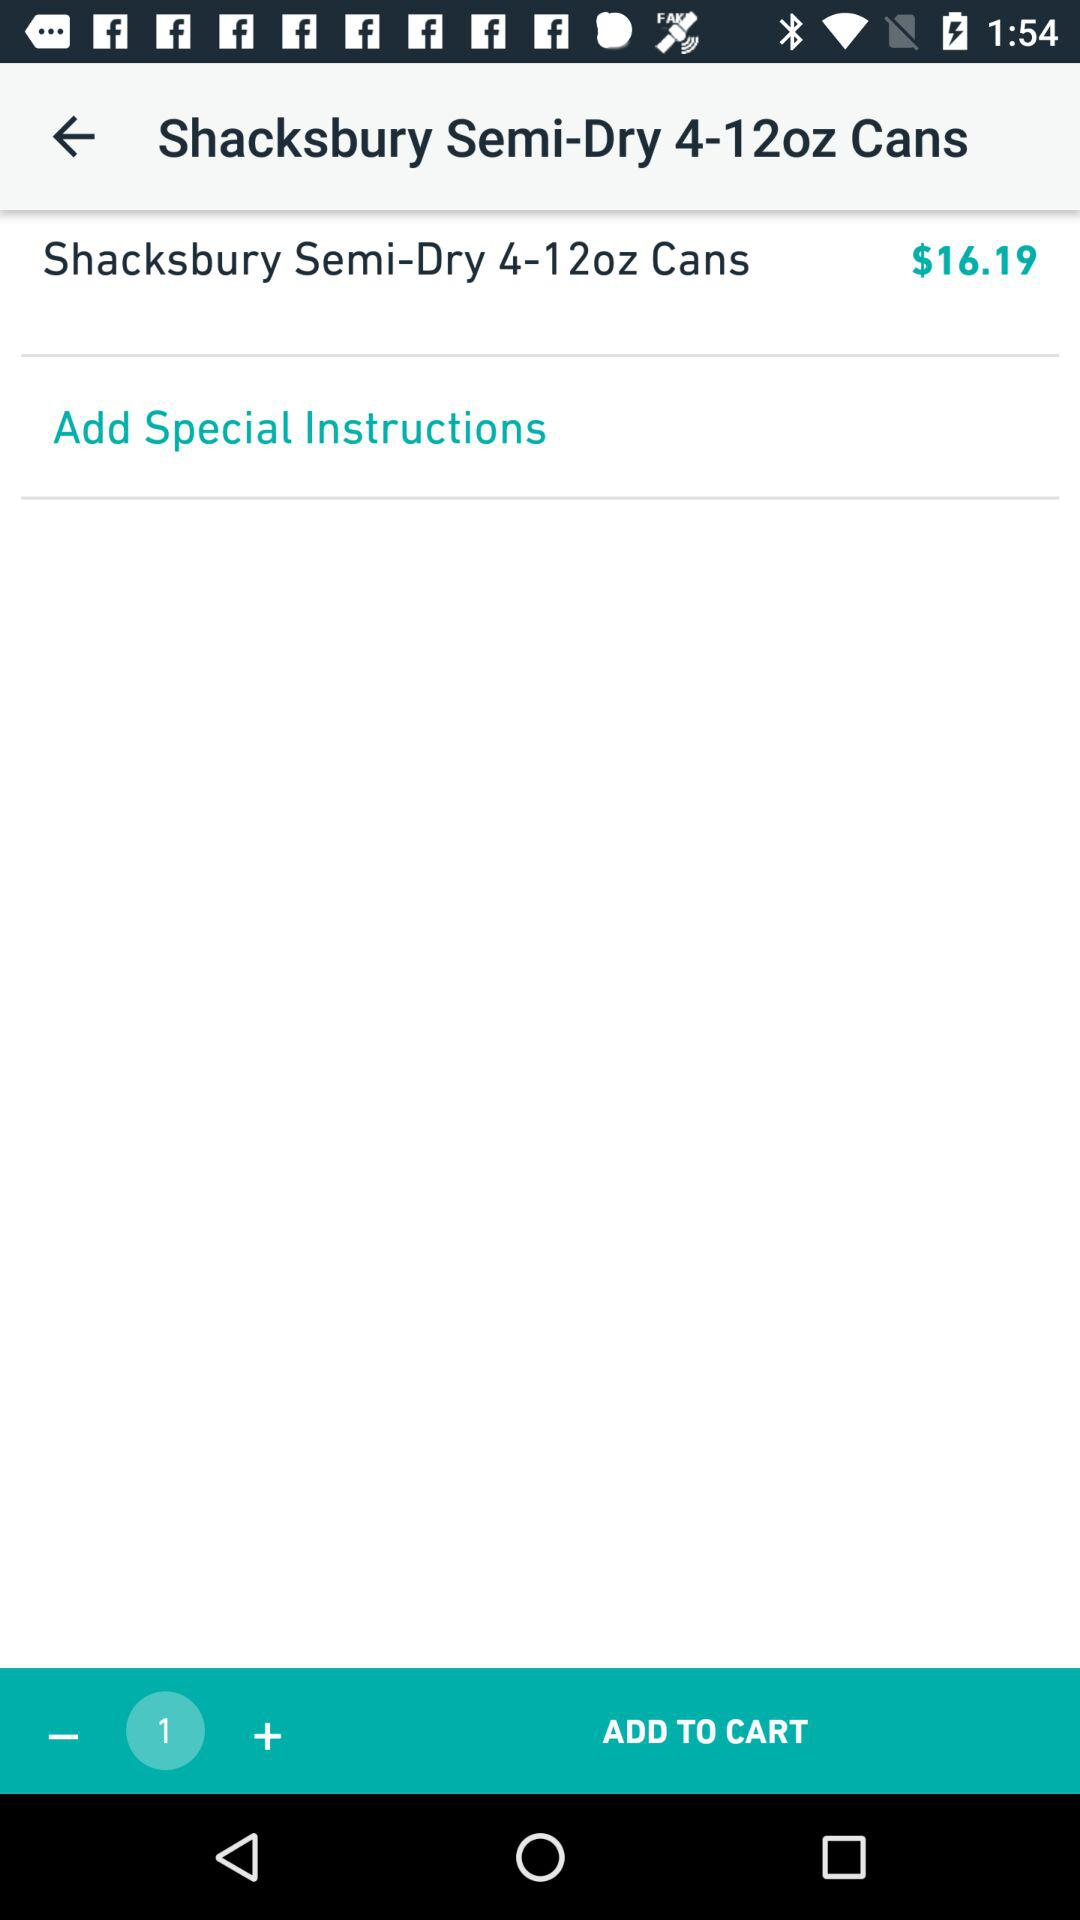How many Shacksbury Semi-Dry 4-12oz Cans are in the cart?
Answer the question using a single word or phrase. 1 